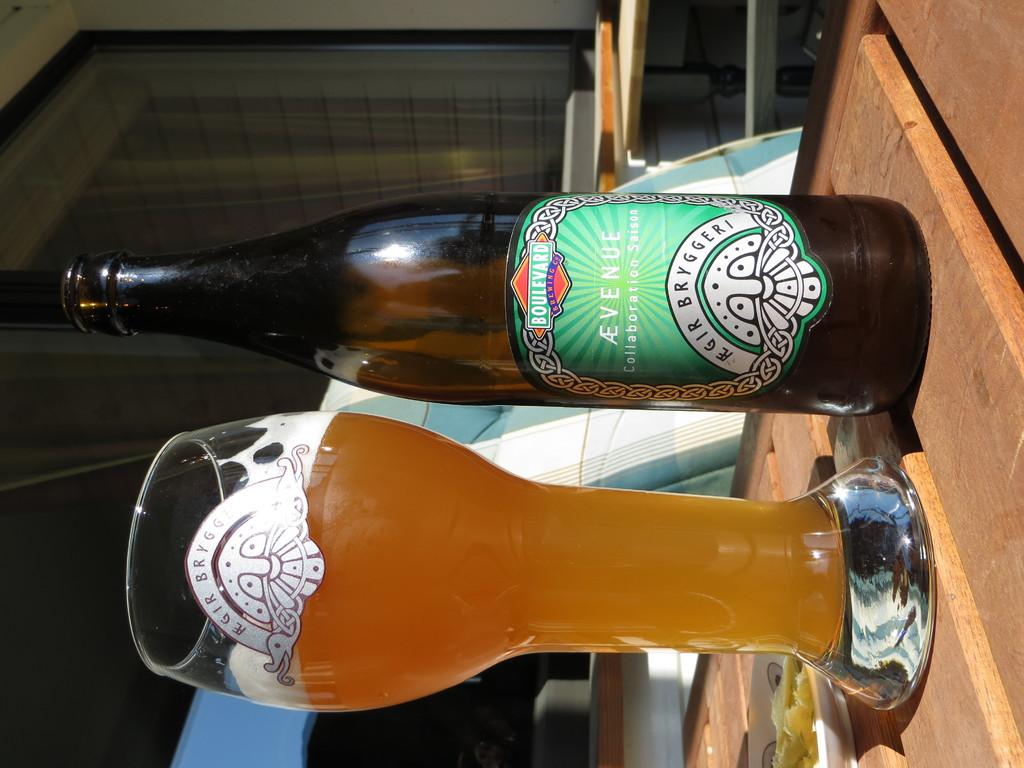What type of glass is visible in the image? There is a beer glass in the image. What is the other beverage-related item in the image? There is a beer bottle with a label in the image. What type of wall can be seen in the image? There is a glass wall in the image. What type of rod is being used to stir the beer in the image? There is no rod present in the image, and the beer is not being stirred. 